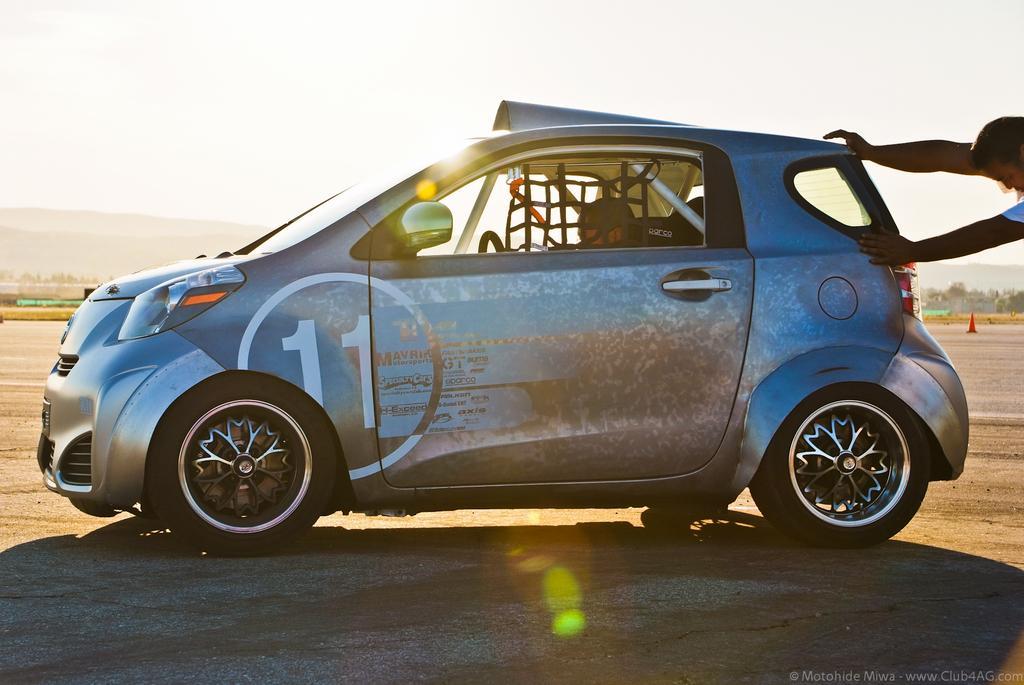Please provide a concise description of this image. At the top we can see a sky and it seems like a sunny day. These are hills, trees. This is a traffic cone. We can see a car and a person is sitting inside it. At the right side of the picture we can see a person pushing a car with his hands. 